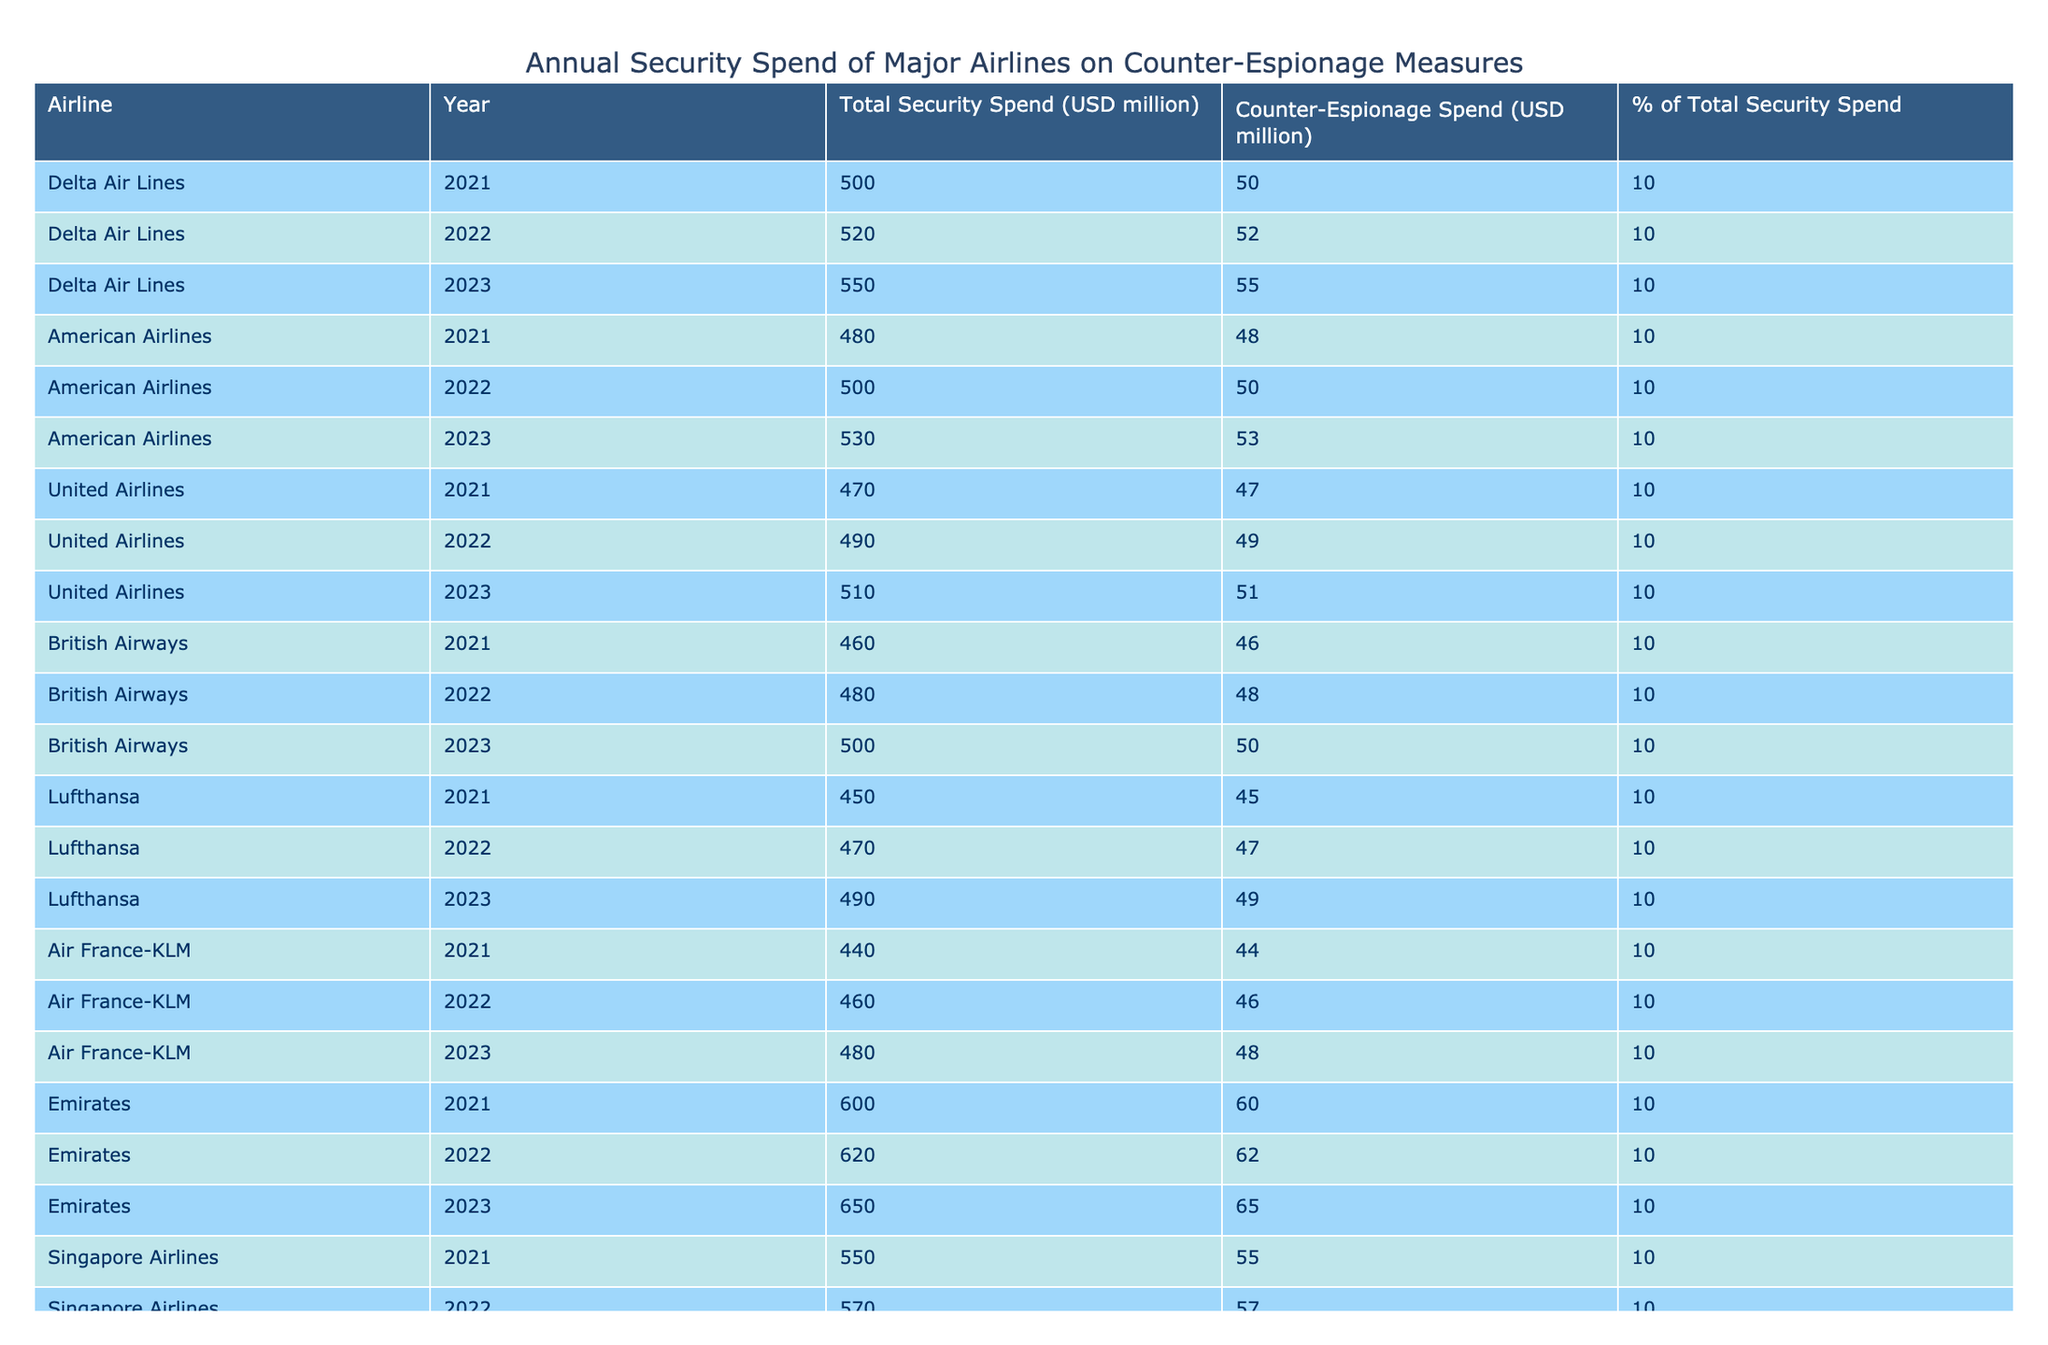What was the total security spend for Delta Air Lines in 2023? According to the table, Delta Air Lines had a total security spend of 550 million USD in 2023.
Answer: 550 million USD Which airline spent the most on counter-espionage measures in 2022? Reviewing the table for counter-espionage spending in 2022, Emirates spent 62 million USD, which is the highest compared to other airlines.
Answer: Emirates What is the percentage of total security spend that American Airlines allocated to counter-espionage measures in 2021? The table shows that American Airlines allocated 10% of its total security spend to counter-espionage measures in 2021.
Answer: 10% How much was the total security spend for Lufthansa over the three years combined? Adding Lufthansa's total security spend for 2021, 2022, and 2023, we have: 450 million + 470 million + 490 million = 1410 million USD.
Answer: 1410 million USD Did British Airways increase its counter-espionage spending from 2021 to 2023? Observing the counter-espionage spend for British Airways, it increased from 46 million USD in 2021 to 50 million USD in 2023, indicating an increase.
Answer: Yes What was the average counter-espionage spending for Singapore Airlines from 2021 to 2023? The counter-espionage spending for Singapore Airlines was 55 million USD in 2021, 57 million USD in 2022, and 60 million USD in 2023. The average is (55 + 57 + 60) / 3 = 57.33 million USD.
Answer: 57.33 million USD Which airline had the lowest total security spend in 2021? By examining total security spend data for 2021, Air France-KLM had the lowest spend of 440 million USD that year.
Answer: Air France-KLM Is the counter-espionage spend for United Airlines in 2023 lower than that of American Airlines in the same year? In 2023, United Airlines spent 51 million USD on counter-espionage, while American Airlines spent 53 million USD, hence United Airlines' spend is lower.
Answer: Yes 